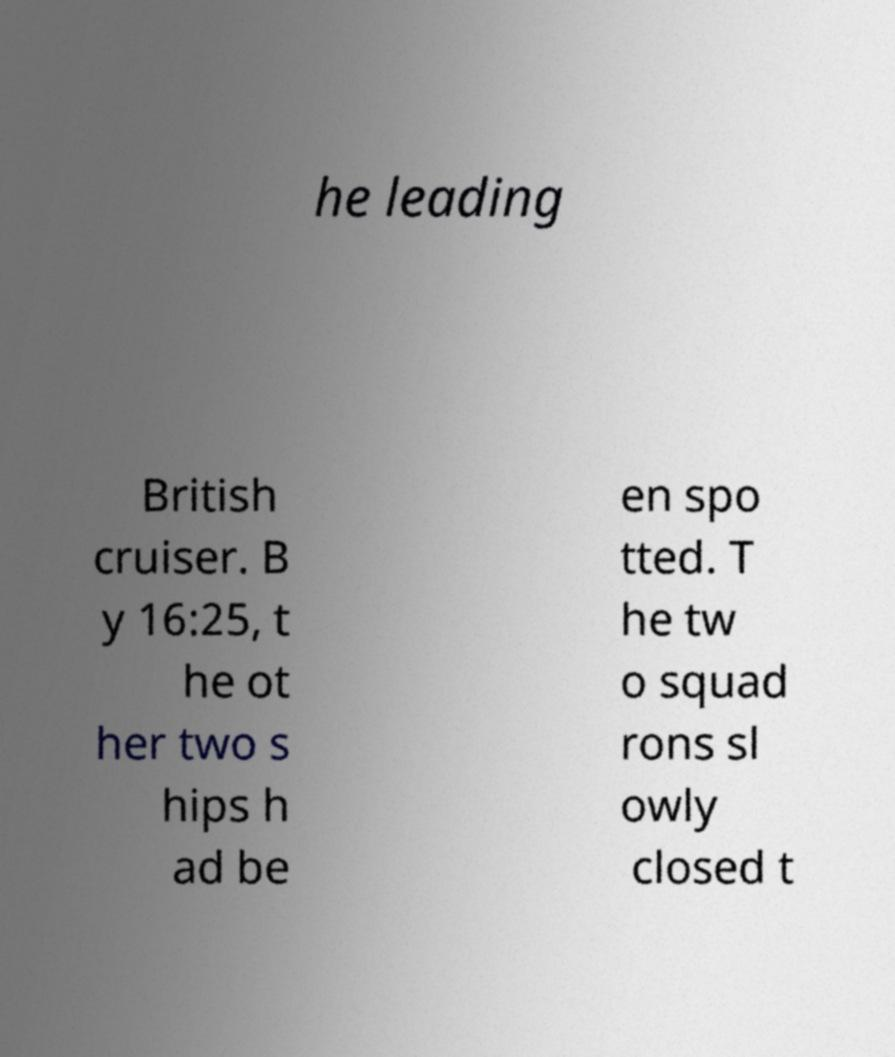Can you read and provide the text displayed in the image?This photo seems to have some interesting text. Can you extract and type it out for me? he leading British cruiser. B y 16:25, t he ot her two s hips h ad be en spo tted. T he tw o squad rons sl owly closed t 